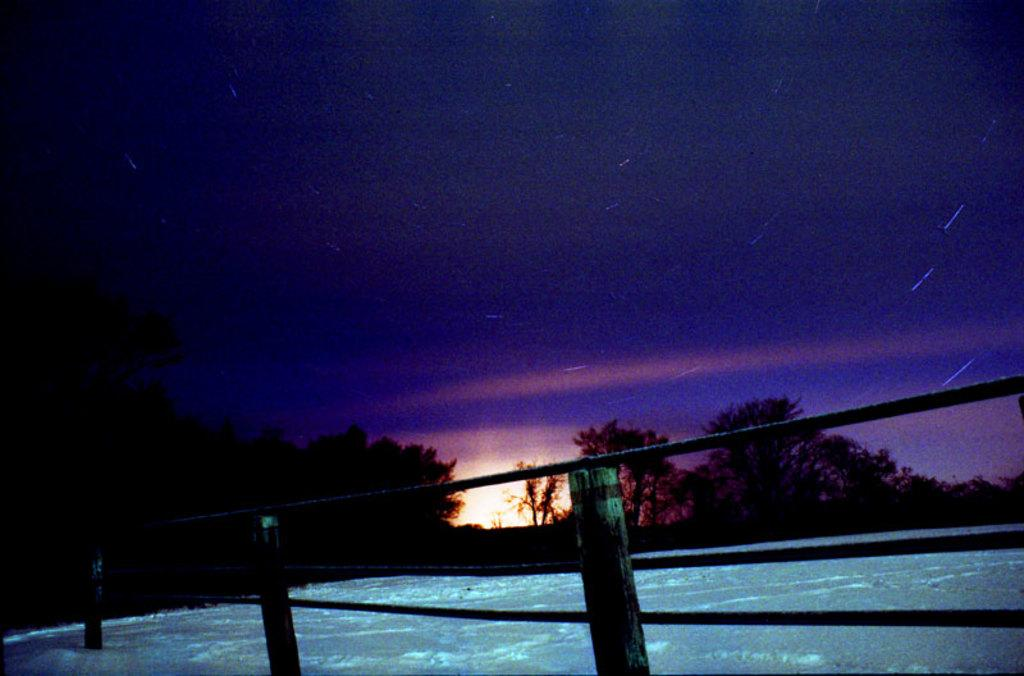What type of weather is depicted in the image? There is snow in the image, indicating a winter scene. What can be seen in the image besides the snow? There is fencing and trees visible in the image. What is visible in the background of the image? The sky is visible in the image, and clouds are present in the sky. Who is the father of the person competing in the show in the image? There is no person competing in a show in the image; it features snow, fencing, trees, and a sky with clouds. 